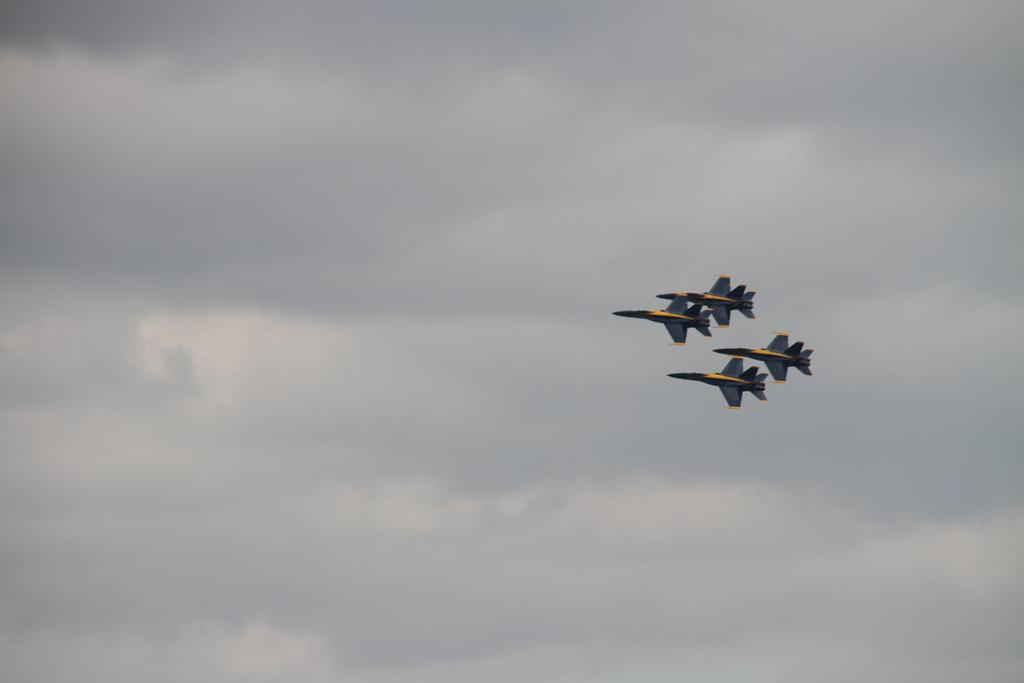What is the main subject of the image? The main subject of the image is planes. Where are the planes located in the image? The planes are in the middle of the image. What can be seen in the background of the image? There are clouds visible in the sky behind the planes. How many dogs can be seen attempting to use the hydrant in the image? There are no dogs or hydrants present in the image. 